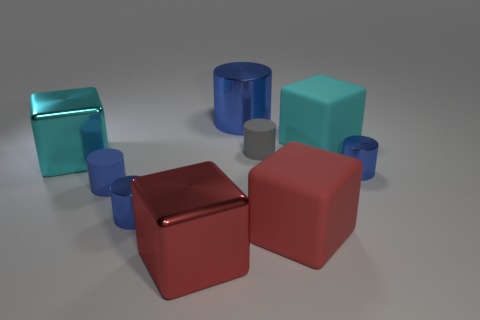Subtract all brown blocks. How many blue cylinders are left? 4 Subtract all gray cylinders. How many cylinders are left? 4 Subtract all blue matte cylinders. How many cylinders are left? 4 Add 1 small cyan metallic cylinders. How many objects exist? 10 Subtract all gray cylinders. Subtract all green spheres. How many cylinders are left? 4 Subtract all cubes. How many objects are left? 5 Add 4 blue rubber cylinders. How many blue rubber cylinders are left? 5 Add 2 yellow shiny things. How many yellow shiny things exist? 2 Subtract 0 yellow spheres. How many objects are left? 9 Subtract all big red matte things. Subtract all big rubber things. How many objects are left? 6 